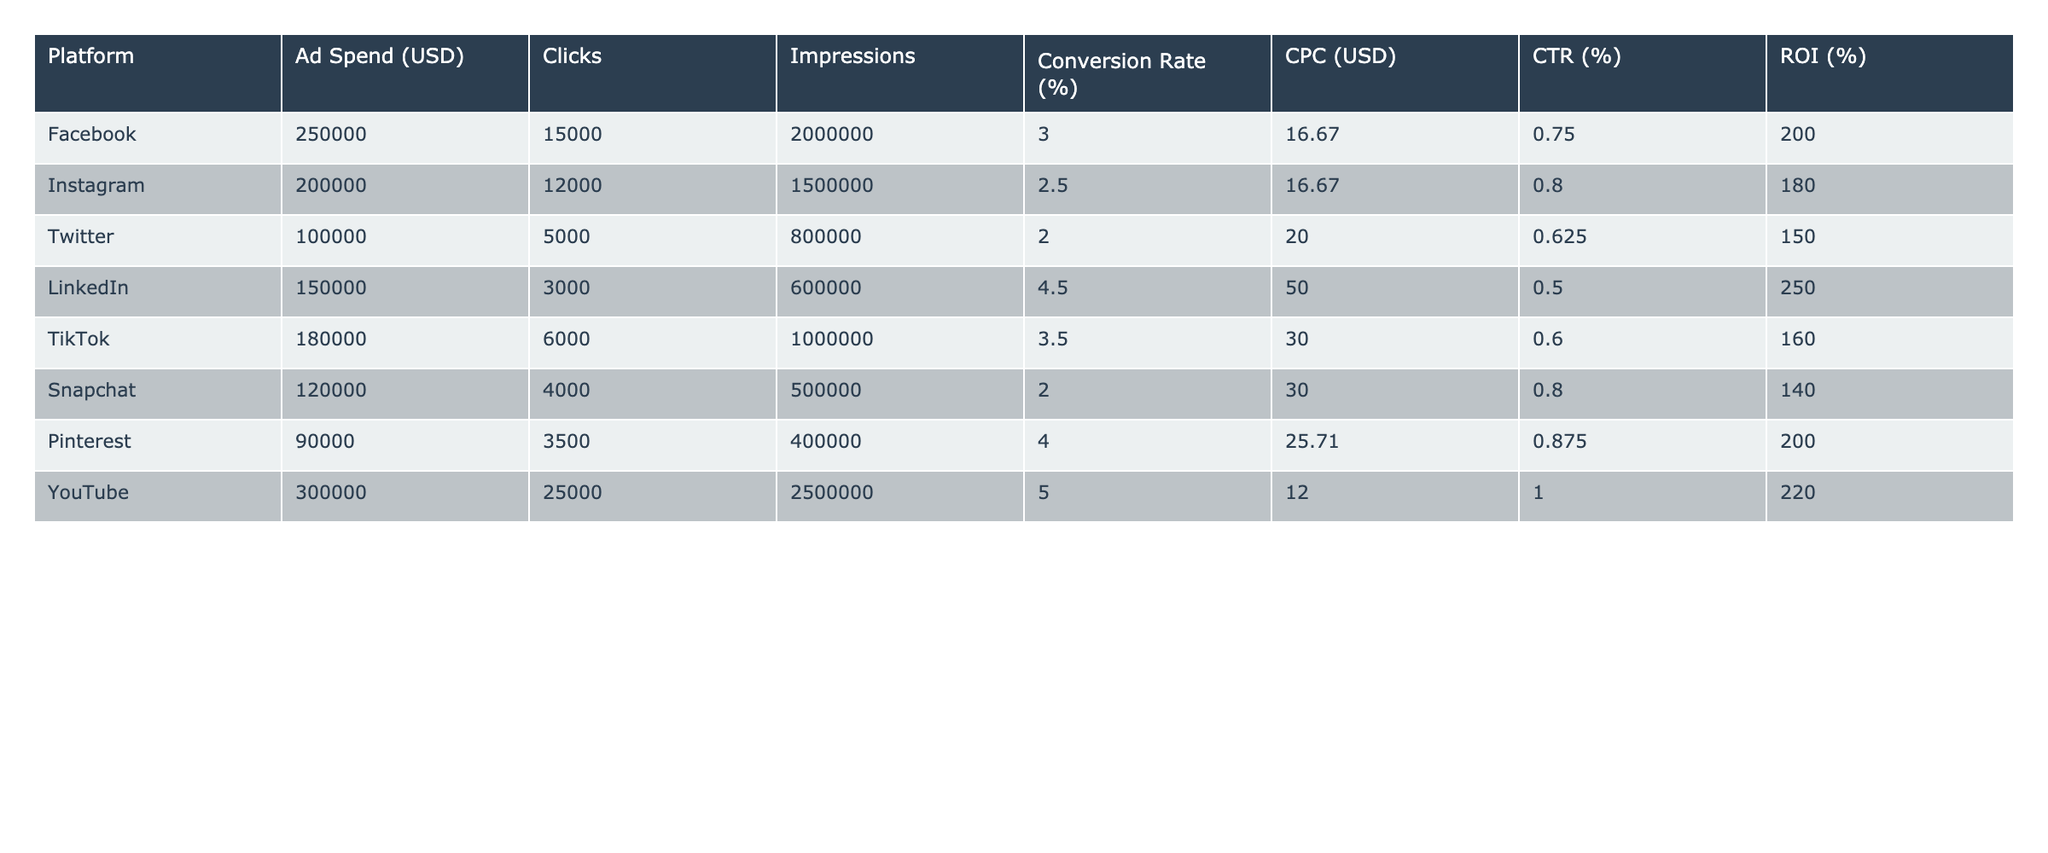What is the total ad spend for all platforms combined? To find the total ad spend, we simply need to sum the individual ad spends for each platform: 250,000 + 200,000 + 100,000 + 150,000 + 180,000 + 120,000 + 90,000 + 300,000 = 1,490,000.
Answer: 1,490,000 Which platform has the highest conversion rate? From the table, we compare the conversion rates: Facebook (3.0%), Instagram (2.5%), Twitter (2.0%), LinkedIn (4.5%), TikTok (3.5%), Snapchat (2.0%), Pinterest (4.0%), and YouTube (5.0%). YouTube has the highest at 5.0%.
Answer: YouTube What is the average cost-per-click (CPC) across all platforms? To calculate the average CPC, we add up the CPC values: 16.67 + 16.67 + 20.00 + 50.00 + 30.00 + 30.00 + 25.71 + 12.00 = 201.05. Then, divide by the number of platforms (8): 201.05 / 8 ≈ 25.13.
Answer: 25.13 Is the Click-Through Rate (CTR) for Twitter higher than that for Snapchat? The CTR for Twitter is 0.625% and for Snapchat is 0.8%. Since 0.625% is less than 0.8%, the statement is false.
Answer: No What is the ROI difference between LinkedIn and Instagram? We find the ROI for each: LinkedIn has 250% and Instagram has 180%. The difference is 250% - 180% = 70%.
Answer: 70% Which platform has the lowest number of clicks? By examining the clicks for each platform, LinkedIn has 3,000 clicks, which is the lowest compared to the others: 15,000 (Facebook), 12,000 (Instagram), 5,000 (Twitter), 6,000 (TikTok), 4,000 (Snapchat), 3,500 (Pinterest), and 25,000 (YouTube).
Answer: LinkedIn How do the ad spends for Facebook and YouTube compare? Facebook's ad spend is 250,000 USD and YouTube's is 300,000 USD. Since 300,000 is greater than 250,000, YouTube's ad spend is higher.
Answer: YouTube's ad spend is higher Which platform has the highest CTR and what is its value? The CTR values are: Facebook (0.75%), Instagram (0.80%), Twitter (0.625%), LinkedIn (0.5%), TikTok (0.6%), Snapchat (0.8%), Pinterest (0.875%), and YouTube (1.0%). YouTube has the highest CTR at 1.0%.
Answer: YouTube, 1.0% If we combine the conversions for Pinterest and Snapchat, what is that total? The conversion data is not directly provided, but we can indirectly consider their conversion rates: Pinterest has 4.0% and Snapchat has 2.0%. To find the total conversion "value," it's simpler to recognize we don't have a direct number of conversions here without knowing total clicks for each. Thus we cannot definitively answer without that information.
Answer: N/A What percentage of the total ad spend is attributed to TikTok? TikTok's ad spend is 180,000 USD. The total ad spend is 1,490,000 USD. To find the percentage: (180,000 / 1,490,000) * 100 ≈ 12.08%.
Answer: 12.08% 